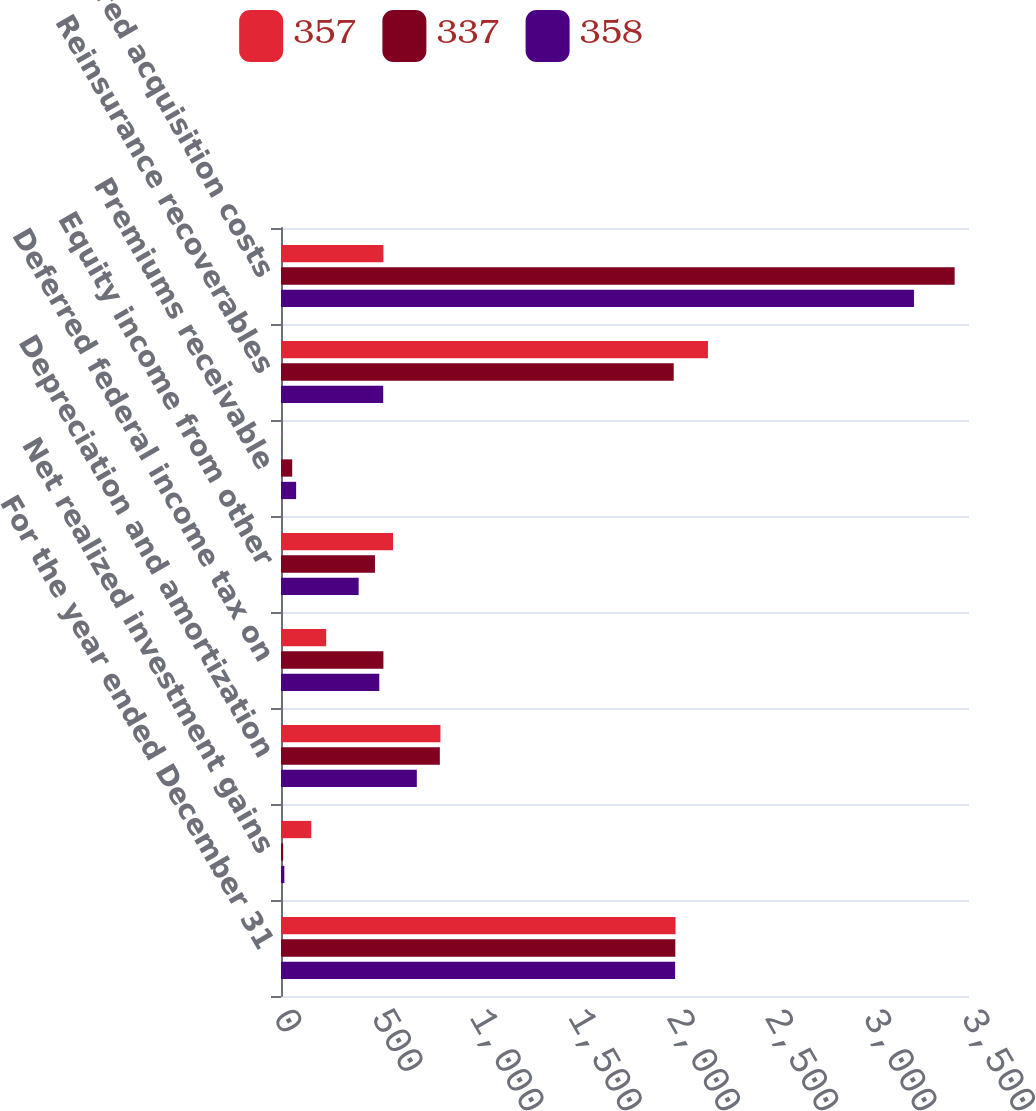Convert chart to OTSL. <chart><loc_0><loc_0><loc_500><loc_500><stacked_bar_chart><ecel><fcel>For the year ended December 31<fcel>Net realized investment gains<fcel>Depreciation and amortization<fcel>Deferred federal income tax on<fcel>Equity income from other<fcel>Premiums receivable<fcel>Reinsurance recoverables<fcel>Deferred acquisition costs<nl><fcel>357<fcel>2007<fcel>154<fcel>811<fcel>230<fcel>570<fcel>4<fcel>2172<fcel>521<nl><fcel>337<fcel>2006<fcel>11<fcel>808<fcel>521<fcel>478<fcel>57<fcel>1998<fcel>3427<nl><fcel>358<fcel>2005<fcel>17<fcel>691<fcel>500<fcel>395<fcel>77<fcel>520<fcel>3220<nl></chart> 